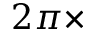<formula> <loc_0><loc_0><loc_500><loc_500>2 \pi \times</formula> 